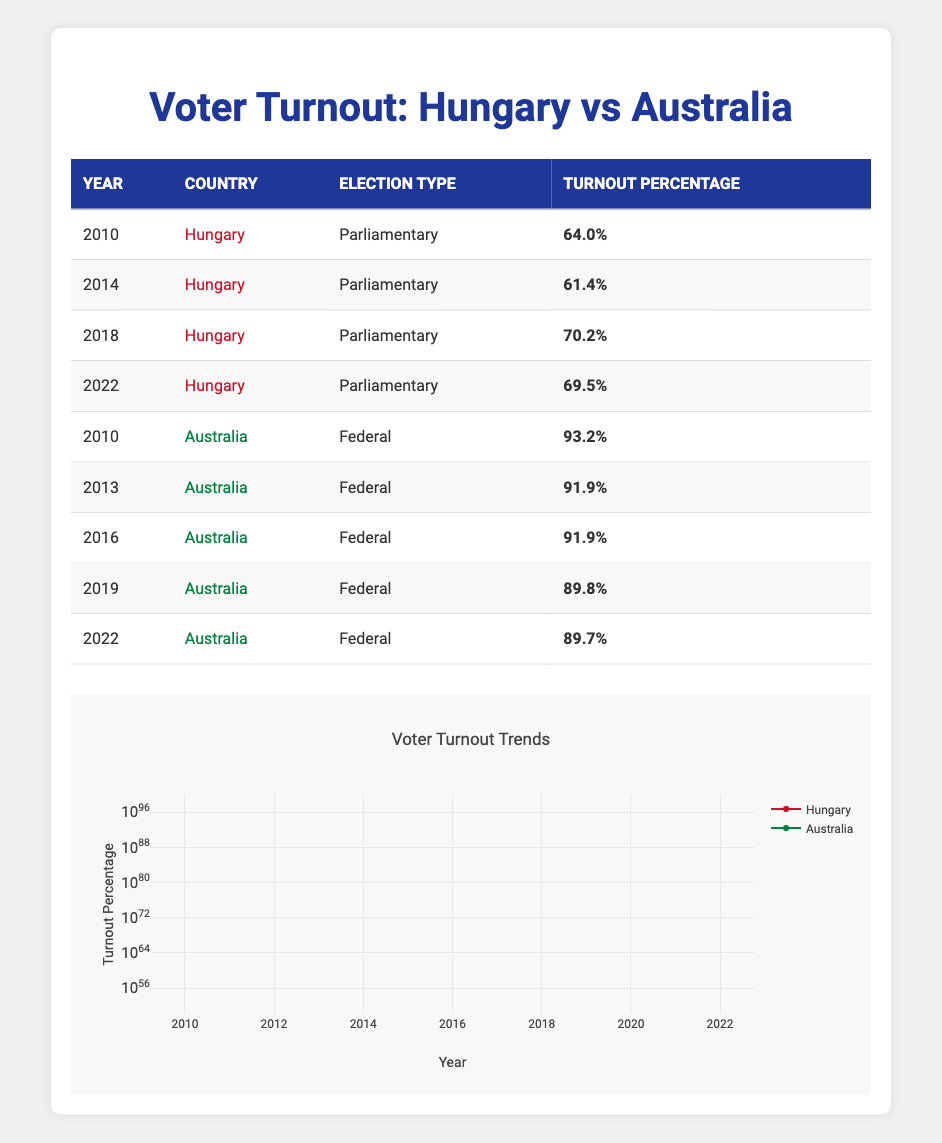What was the voter turnout percentage in Hungary in 2014? The table shows that in 2014, the voter turnout percentage in Hungary for the parliamentary election was 61.4%.
Answer: 61.4% What was the difference in voter turnout percentage between Australia in 2010 and Hungary in 2010? In 2010, Australia's turnout was 93.2% and Hungary's was 64.0%. To find the difference, subtract Hungary's percentage from Australia's: 93.2 - 64.0 = 29.2%.
Answer: 29.2% Did voter turnout in Hungary increase from 2014 to 2018? The table indicates that the turnout in Hungary was 61.4% in 2014 and 70.2% in 2018. Since 70.2% is greater than 61.4%, it confirms that there was an increase.
Answer: Yes What was the average voter turnout percentage for Hungary across the years listed? To find the average, sum the turnout percentages: 64.0 + 61.4 + 70.2 + 69.5 = 265.1. There are 4 data points. So, the average is 265.1 / 4 = 66.275%.
Answer: 66.28% Was there a decline in voter turnout in Australia from 2016 to 2019? In 2016 the turnout was 91.9% and in 2019 it was 89.8%. Since 89.8% is lower than 91.9%, there was indeed a decline in turnout.
Answer: Yes Which country had a higher voter turnout in 2022 and by how much? In 2022, Hungary had a turnout of 69.5%, while Australia had 89.7%. To find who had a higher turnout, compare the two values. The difference is 89.7 - 69.5 = 20.2%. Therefore, Australia had the higher turnout.
Answer: Australia by 20.2% What is the range of voter turnout percentages in Hungary from 2010 to 2022? The table shows the turnout percentages for Hungary are 64.0%, 61.4%, 70.2%, and 69.5%. The highest is 70.2% and the lowest is 61.4%. The range can be found by subtracting the lowest from the highest: 70.2 - 61.4 = 8.8%.
Answer: 8.8% In which year did Australia have the lowest voter turnout according to the table? The table shows Australia had percentages of 93.2%, 91.9%, 91.9%, 89.8%, and 89.7% in the years listed. The lowest turnout was 89.7% in 2022.
Answer: 2022 What was the percentage drop in voter turnout for Australia from 2010 to 2022? The voter turnout was 93.2% in 2010 and 89.7% in 2022. To find the drop, subtract 89.7 from 93.2: 93.2 - 89.7 = 3.5%.
Answer: 3.5% 